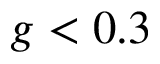<formula> <loc_0><loc_0><loc_500><loc_500>g < 0 . 3</formula> 